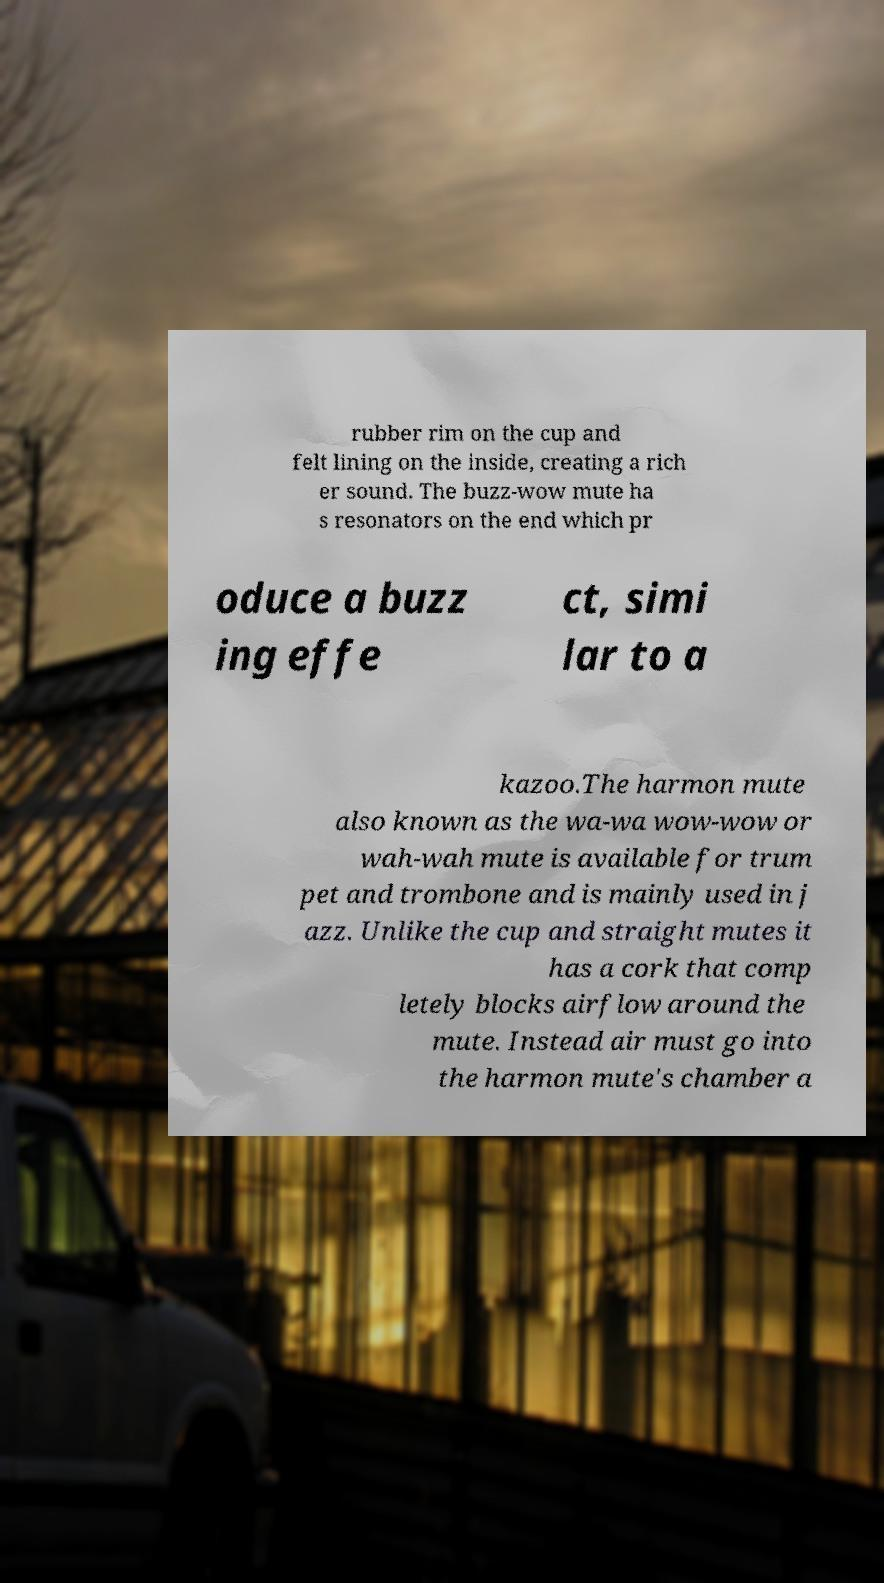For documentation purposes, I need the text within this image transcribed. Could you provide that? rubber rim on the cup and felt lining on the inside, creating a rich er sound. The buzz-wow mute ha s resonators on the end which pr oduce a buzz ing effe ct, simi lar to a kazoo.The harmon mute also known as the wa-wa wow-wow or wah-wah mute is available for trum pet and trombone and is mainly used in j azz. Unlike the cup and straight mutes it has a cork that comp letely blocks airflow around the mute. Instead air must go into the harmon mute's chamber a 